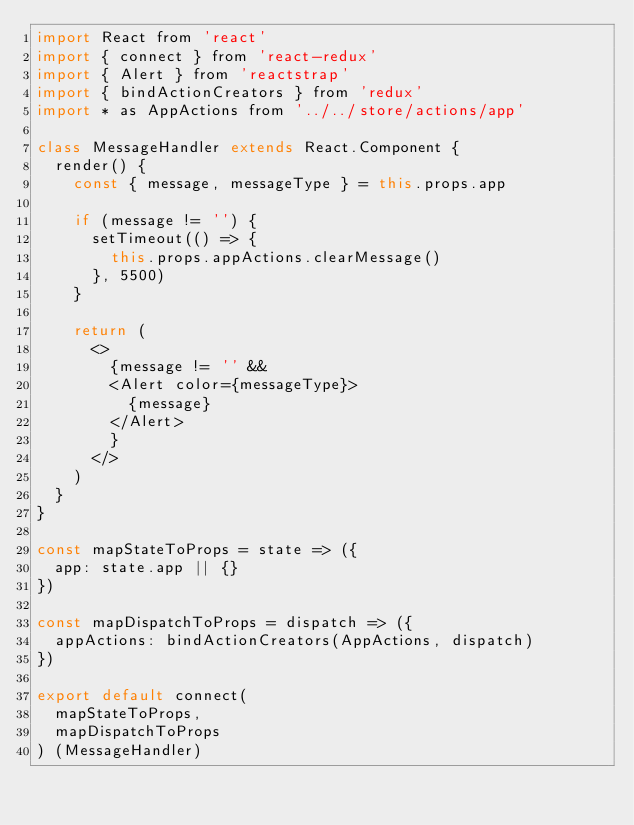<code> <loc_0><loc_0><loc_500><loc_500><_JavaScript_>import React from 'react'
import { connect } from 'react-redux'
import { Alert } from 'reactstrap'
import { bindActionCreators } from 'redux'
import * as AppActions from '../../store/actions/app'

class MessageHandler extends React.Component {
  render() {
    const { message, messageType } = this.props.app

    if (message != '') {
      setTimeout(() => {
        this.props.appActions.clearMessage()
      }, 5500)
    }

    return (
      <>
        {message != '' &&
        <Alert color={messageType}>
          {message}
        </Alert>
        }
      </>
    )
  }
}

const mapStateToProps = state => ({
  app: state.app || {}
})

const mapDispatchToProps = dispatch => ({
  appActions: bindActionCreators(AppActions, dispatch)
})

export default connect(
  mapStateToProps, 
  mapDispatchToProps
) (MessageHandler)
</code> 